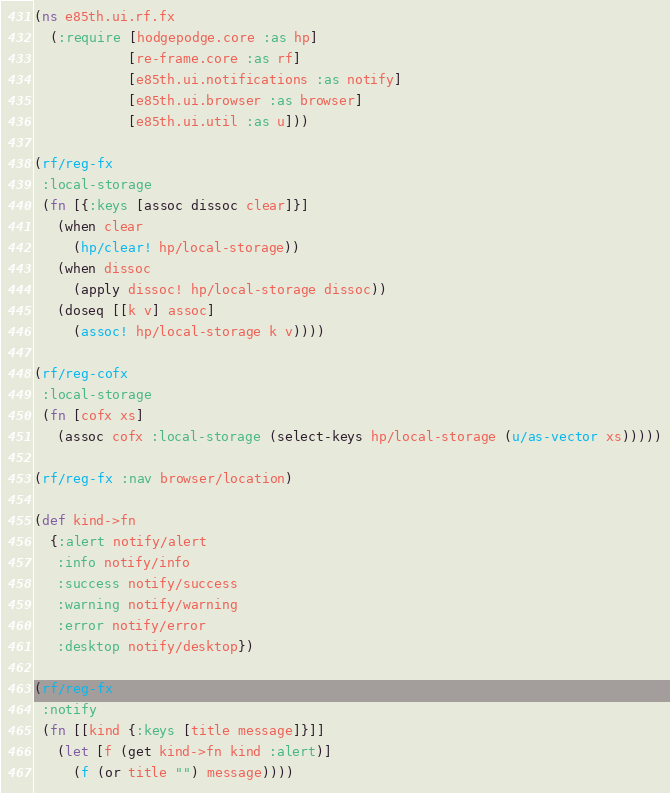Convert code to text. <code><loc_0><loc_0><loc_500><loc_500><_Clojure_>(ns e85th.ui.rf.fx
  (:require [hodgepodge.core :as hp]
            [re-frame.core :as rf]
            [e85th.ui.notifications :as notify]
            [e85th.ui.browser :as browser]
            [e85th.ui.util :as u]))

(rf/reg-fx
 :local-storage
 (fn [{:keys [assoc dissoc clear]}]
   (when clear
     (hp/clear! hp/local-storage))
   (when dissoc
     (apply dissoc! hp/local-storage dissoc))
   (doseq [[k v] assoc]
     (assoc! hp/local-storage k v))))

(rf/reg-cofx
 :local-storage
 (fn [cofx xs]
   (assoc cofx :local-storage (select-keys hp/local-storage (u/as-vector xs)))))

(rf/reg-fx :nav browser/location)

(def kind->fn
  {:alert notify/alert
   :info notify/info
   :success notify/success
   :warning notify/warning
   :error notify/error
   :desktop notify/desktop})

(rf/reg-fx
 :notify
 (fn [[kind {:keys [title message]}]]
   (let [f (get kind->fn kind :alert)]
     (f (or title "") message))))
</code> 